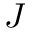Convert formula to latex. <formula><loc_0><loc_0><loc_500><loc_500>J</formula> 